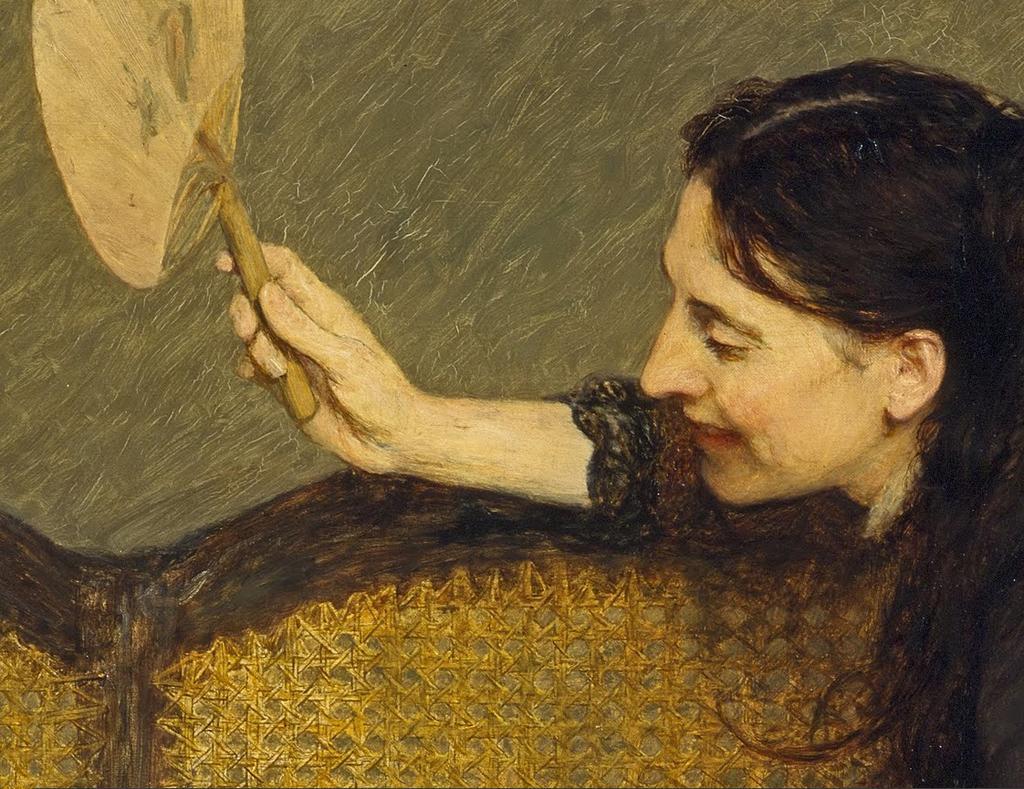Can you describe this image briefly? In this image I can see a painting of the person and the person is holding some object. I can also see a bench which is in brown color. 